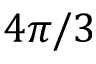Convert formula to latex. <formula><loc_0><loc_0><loc_500><loc_500>4 \pi / 3</formula> 